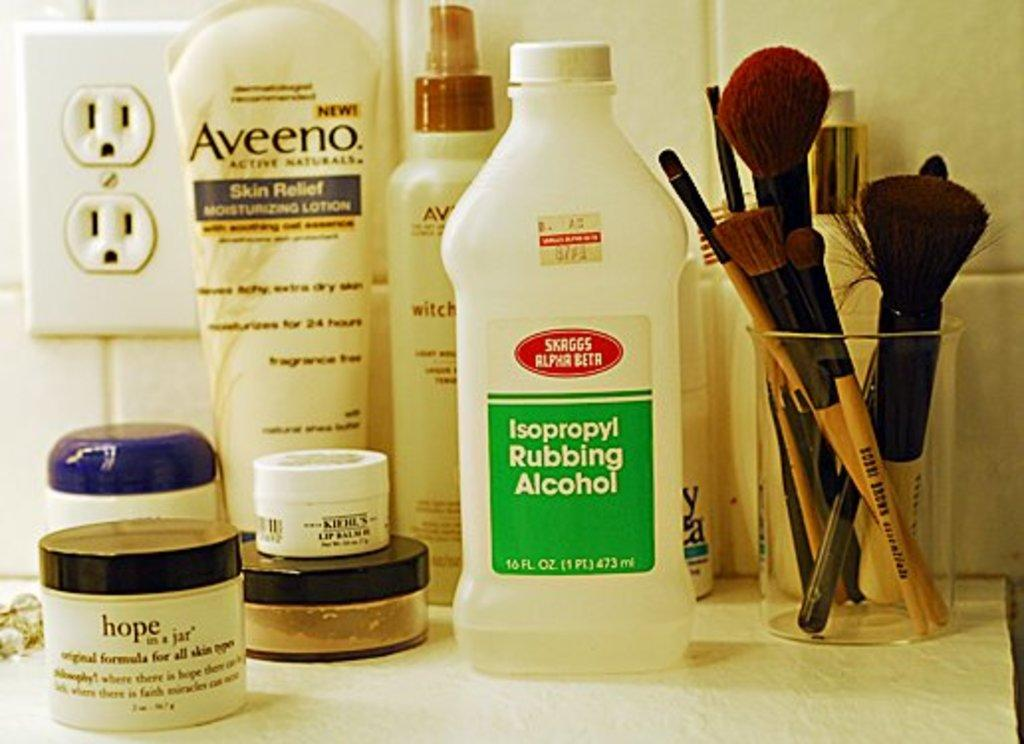<image>
Describe the image concisely. A bottle of Skaggs Alpha Beta rubbing alcohol sits on a bathroom counter. 